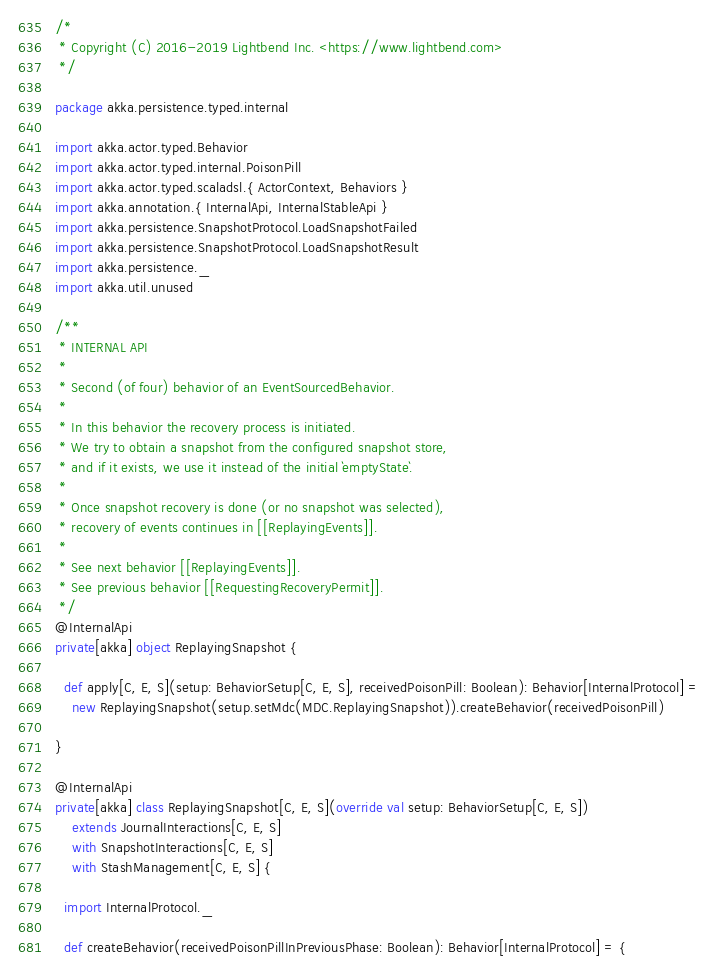<code> <loc_0><loc_0><loc_500><loc_500><_Scala_>/*
 * Copyright (C) 2016-2019 Lightbend Inc. <https://www.lightbend.com>
 */

package akka.persistence.typed.internal

import akka.actor.typed.Behavior
import akka.actor.typed.internal.PoisonPill
import akka.actor.typed.scaladsl.{ ActorContext, Behaviors }
import akka.annotation.{ InternalApi, InternalStableApi }
import akka.persistence.SnapshotProtocol.LoadSnapshotFailed
import akka.persistence.SnapshotProtocol.LoadSnapshotResult
import akka.persistence._
import akka.util.unused

/**
 * INTERNAL API
 *
 * Second (of four) behavior of an EventSourcedBehavior.
 *
 * In this behavior the recovery process is initiated.
 * We try to obtain a snapshot from the configured snapshot store,
 * and if it exists, we use it instead of the initial `emptyState`.
 *
 * Once snapshot recovery is done (or no snapshot was selected),
 * recovery of events continues in [[ReplayingEvents]].
 *
 * See next behavior [[ReplayingEvents]].
 * See previous behavior [[RequestingRecoveryPermit]].
 */
@InternalApi
private[akka] object ReplayingSnapshot {

  def apply[C, E, S](setup: BehaviorSetup[C, E, S], receivedPoisonPill: Boolean): Behavior[InternalProtocol] =
    new ReplayingSnapshot(setup.setMdc(MDC.ReplayingSnapshot)).createBehavior(receivedPoisonPill)

}

@InternalApi
private[akka] class ReplayingSnapshot[C, E, S](override val setup: BehaviorSetup[C, E, S])
    extends JournalInteractions[C, E, S]
    with SnapshotInteractions[C, E, S]
    with StashManagement[C, E, S] {

  import InternalProtocol._

  def createBehavior(receivedPoisonPillInPreviousPhase: Boolean): Behavior[InternalProtocol] = {</code> 